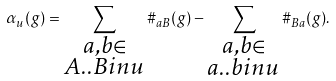Convert formula to latex. <formula><loc_0><loc_0><loc_500><loc_500>\alpha _ { u } ( g ) = \sum _ { \substack { a , b \in \AA \\ A . . B i n u } } \# _ { a B } ( g ) - \sum _ { \substack { a , b \in \AA \\ a . . b i n u } } \# _ { B a } ( g ) .</formula> 